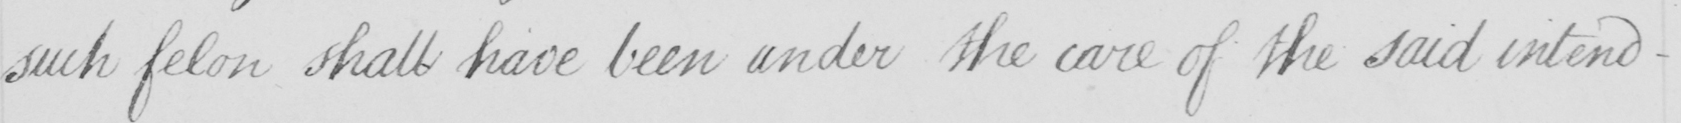Can you tell me what this handwritten text says? such felon shall have been under the care of the said intend- 